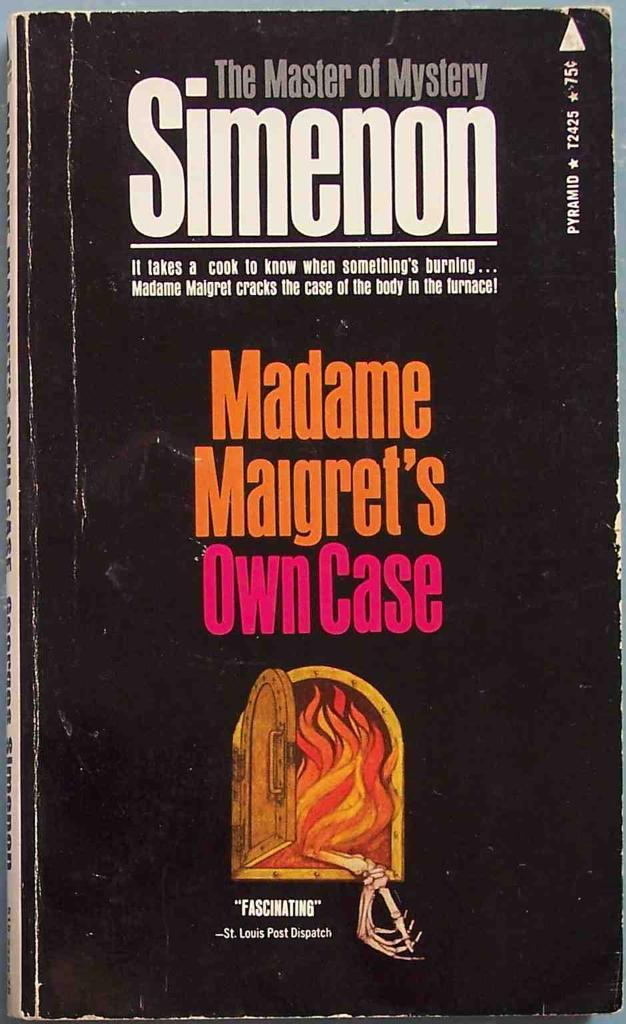Provide a one-sentence caption for the provided image. A vintage copy of Madame Maigret's Own Case. 